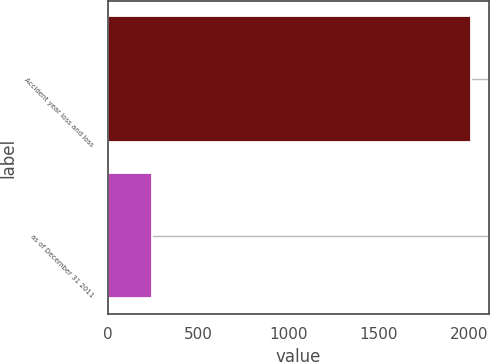<chart> <loc_0><loc_0><loc_500><loc_500><bar_chart><fcel>Accident year loss and loss<fcel>as of December 31 2011<nl><fcel>2010<fcel>248<nl></chart> 